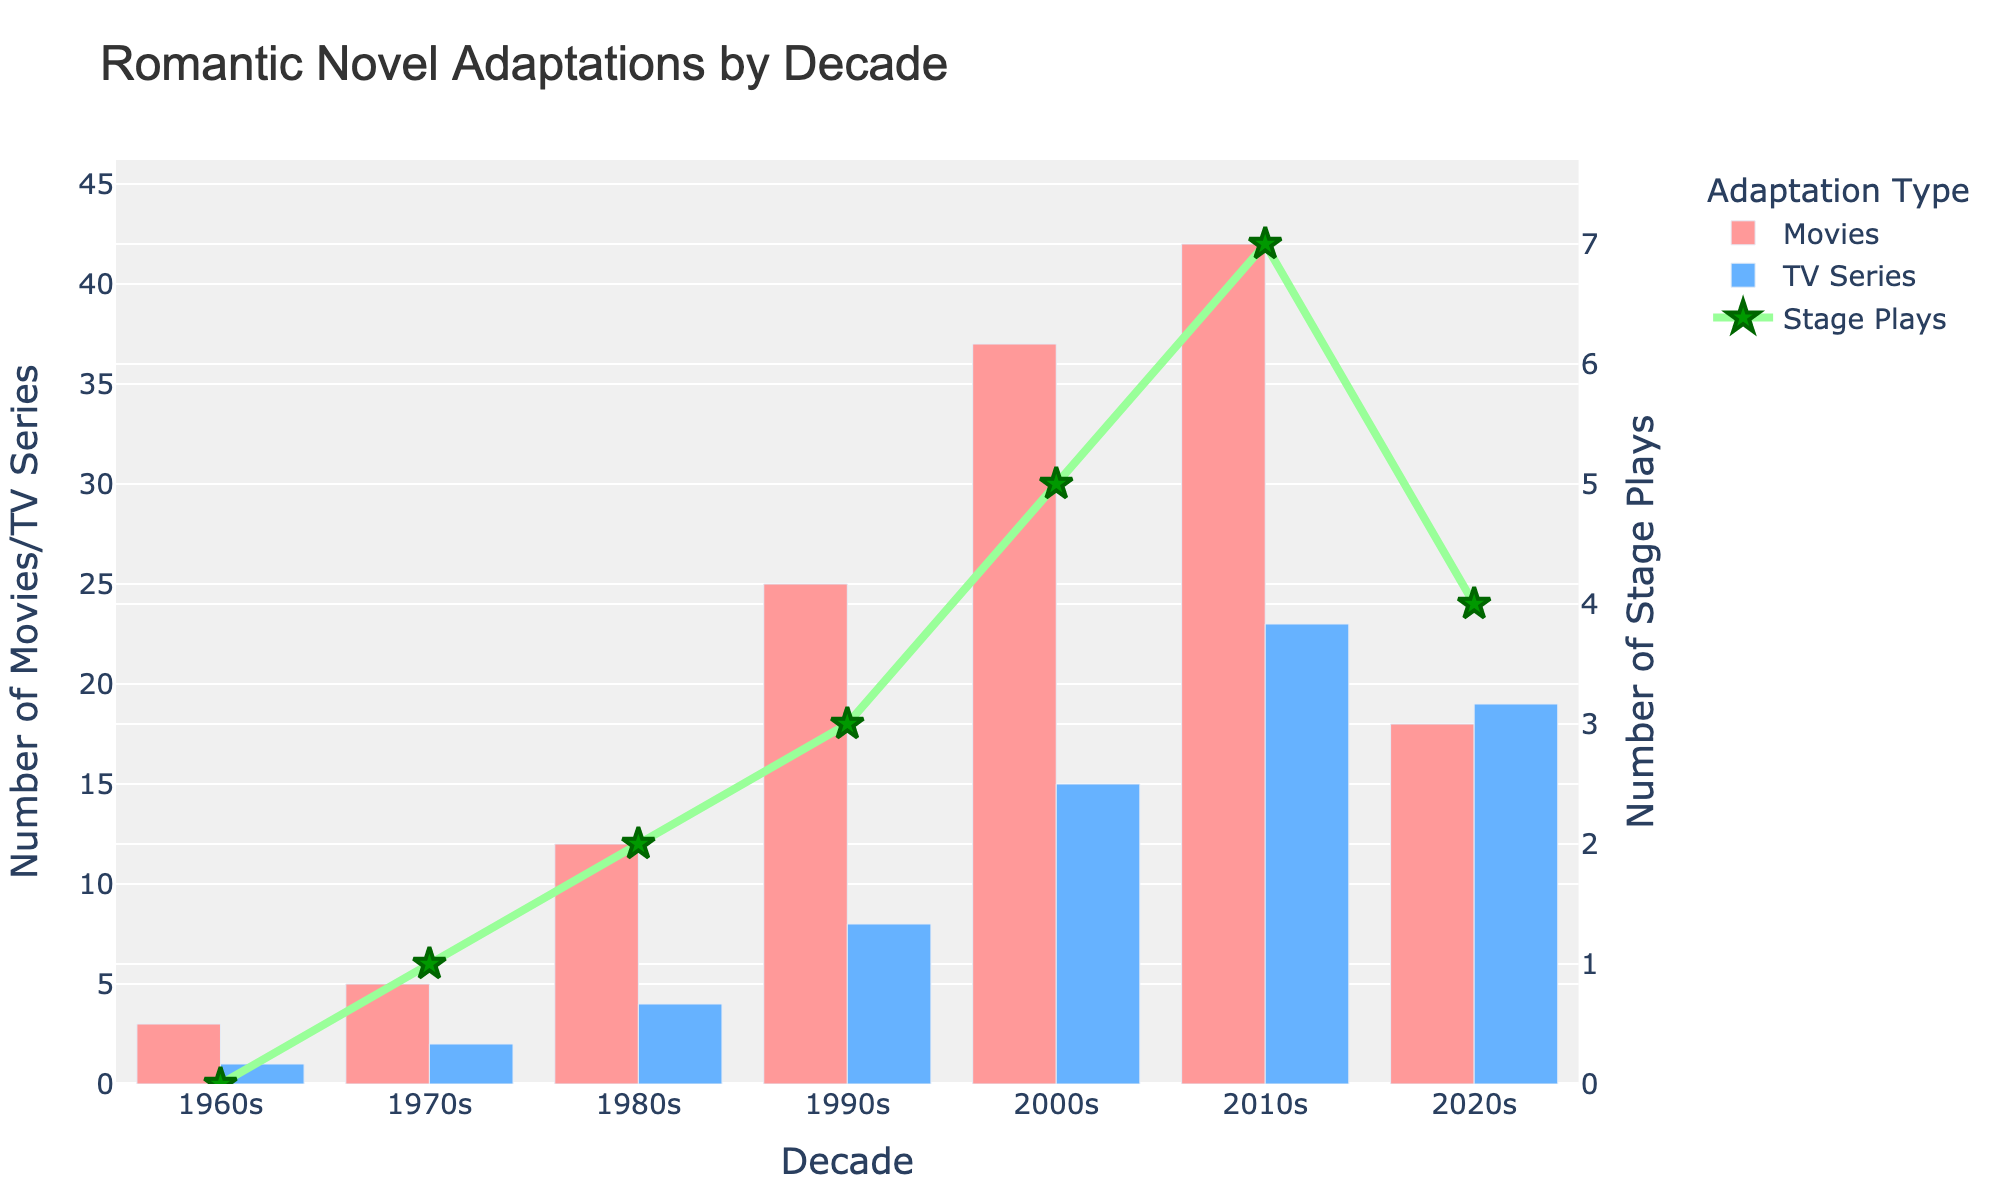How does the number of movie adaptations in the 2010s compare to the 1980s? The 2010s have 42 movie adaptations, while the 1980s have 12. 42 is greater than 12 by a difference of 30.
Answer: 42 is greater by 30 Which decade has the highest number of TV series adaptations? By examining the heights of the blue bars, the 2010s have the highest number of TV series adaptations with 23.
Answer: 2010s What is the average number of stage plays per decade? Sum the number of stage plays (0+1+2+3+5+7+4 = 22) and divide by the number of decades (7). The average is 22/7.
Answer: 3.14 Which type of adaptations increased the most from the 1960s to the 2000s? Compare the increase in the heights of each colored bar and the green line. Movies increase from 3 to 37, TV series from 1 to 15, and stage plays from 0 to 5. Movies have the largest increase (34).
Answer: Movies During which decade did stage plays see the highest increase compared to the previous decade? Observe the green line's trend. The greatest increase in height occurs from the 2000s (5) to the 2010s (7), with an increase of 2.
Answer: 2010s What is the sum of TV series and stage plays in the 2020s? Sum the number of TV series and stage plays in the 2020s (19+4).
Answer: 23 How many more adaptations (movies, TV series, and stage plays combined) were there in the 2000s compared to the 1960s? Sum the adaptations for each decade: 2000s (37+15+5) = 57; 1960s (3+1+0) = 4. The difference is 57–4.
Answer: 53 Which decade has the smallest difference between movies and TV series adaptations? Calculate the difference for each decade and compare: 1960s (2), 1970s (3), 1980s (8), 1990s (17), 2000s (22), 2010s (19), 2020s (-1). The smallest absolute difference is -1 in the 2020s.
Answer: 2020s How many total adaptations were there in the 1990s? Sum the number of movies, TV series, and stage plays in the 1990s (25+8+3).
Answer: 36 